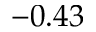<formula> <loc_0><loc_0><loc_500><loc_500>- 0 . 4 3</formula> 